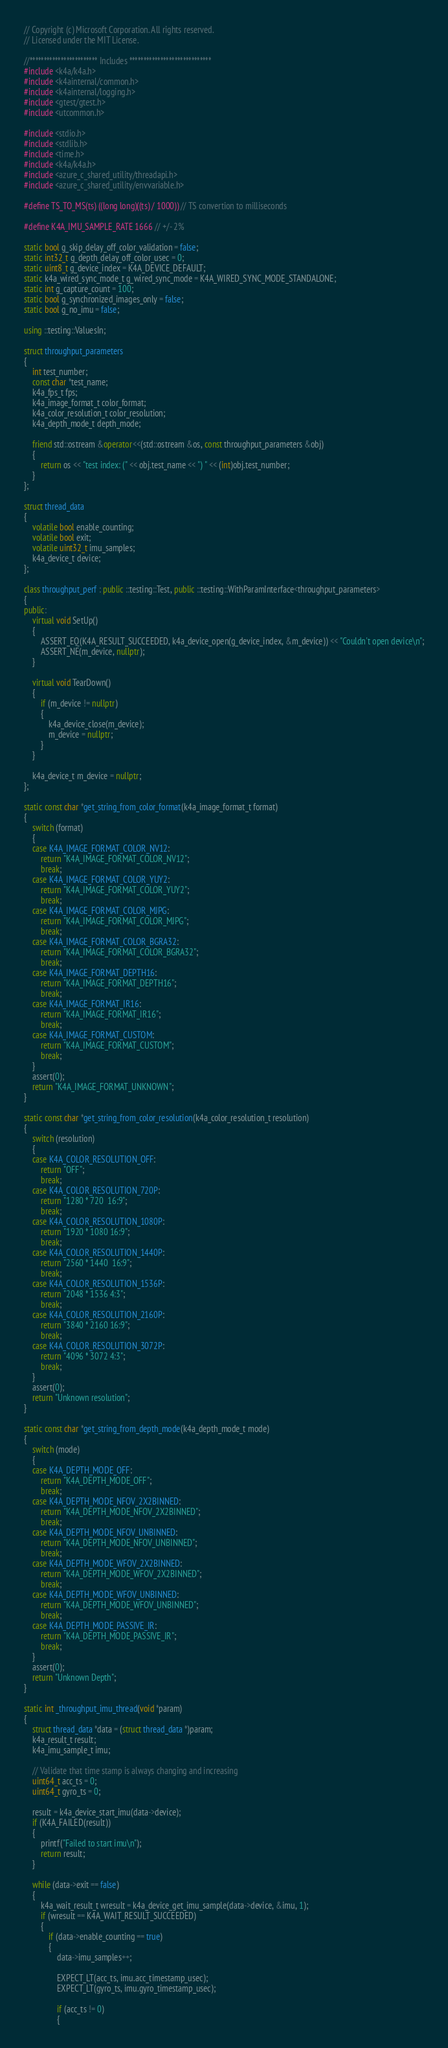<code> <loc_0><loc_0><loc_500><loc_500><_C++_>// Copyright (c) Microsoft Corporation. All rights reserved.
// Licensed under the MIT License.

//************************ Includes *****************************
#include <k4a/k4a.h>
#include <k4ainternal/common.h>
#include <k4ainternal/logging.h>
#include <gtest/gtest.h>
#include <utcommon.h>

#include <stdio.h>
#include <stdlib.h>
#include <time.h>
#include <k4a/k4a.h>
#include <azure_c_shared_utility/threadapi.h>
#include <azure_c_shared_utility/envvariable.h>

#define TS_TO_MS(ts) ((long long)((ts) / 1000)) // TS convertion to milliseconds

#define K4A_IMU_SAMPLE_RATE 1666 // +/- 2%

static bool g_skip_delay_off_color_validation = false;
static int32_t g_depth_delay_off_color_usec = 0;
static uint8_t g_device_index = K4A_DEVICE_DEFAULT;
static k4a_wired_sync_mode_t g_wired_sync_mode = K4A_WIRED_SYNC_MODE_STANDALONE;
static int g_capture_count = 100;
static bool g_synchronized_images_only = false;
static bool g_no_imu = false;

using ::testing::ValuesIn;

struct throughput_parameters
{
    int test_number;
    const char *test_name;
    k4a_fps_t fps;
    k4a_image_format_t color_format;
    k4a_color_resolution_t color_resolution;
    k4a_depth_mode_t depth_mode;

    friend std::ostream &operator<<(std::ostream &os, const throughput_parameters &obj)
    {
        return os << "test index: (" << obj.test_name << ") " << (int)obj.test_number;
    }
};

struct thread_data
{
    volatile bool enable_counting;
    volatile bool exit;
    volatile uint32_t imu_samples;
    k4a_device_t device;
};

class throughput_perf : public ::testing::Test, public ::testing::WithParamInterface<throughput_parameters>
{
public:
    virtual void SetUp()
    {
        ASSERT_EQ(K4A_RESULT_SUCCEEDED, k4a_device_open(g_device_index, &m_device)) << "Couldn't open device\n";
        ASSERT_NE(m_device, nullptr);
    }

    virtual void TearDown()
    {
        if (m_device != nullptr)
        {
            k4a_device_close(m_device);
            m_device = nullptr;
        }
    }

    k4a_device_t m_device = nullptr;
};

static const char *get_string_from_color_format(k4a_image_format_t format)
{
    switch (format)
    {
    case K4A_IMAGE_FORMAT_COLOR_NV12:
        return "K4A_IMAGE_FORMAT_COLOR_NV12";
        break;
    case K4A_IMAGE_FORMAT_COLOR_YUY2:
        return "K4A_IMAGE_FORMAT_COLOR_YUY2";
        break;
    case K4A_IMAGE_FORMAT_COLOR_MJPG:
        return "K4A_IMAGE_FORMAT_COLOR_MJPG";
        break;
    case K4A_IMAGE_FORMAT_COLOR_BGRA32:
        return "K4A_IMAGE_FORMAT_COLOR_BGRA32";
        break;
    case K4A_IMAGE_FORMAT_DEPTH16:
        return "K4A_IMAGE_FORMAT_DEPTH16";
        break;
    case K4A_IMAGE_FORMAT_IR16:
        return "K4A_IMAGE_FORMAT_IR16";
        break;
    case K4A_IMAGE_FORMAT_CUSTOM:
        return "K4A_IMAGE_FORMAT_CUSTOM";
        break;
    }
    assert(0);
    return "K4A_IMAGE_FORMAT_UNKNOWN";
}

static const char *get_string_from_color_resolution(k4a_color_resolution_t resolution)
{
    switch (resolution)
    {
    case K4A_COLOR_RESOLUTION_OFF:
        return "OFF";
        break;
    case K4A_COLOR_RESOLUTION_720P:
        return "1280 * 720  16:9";
        break;
    case K4A_COLOR_RESOLUTION_1080P:
        return "1920 * 1080 16:9";
        break;
    case K4A_COLOR_RESOLUTION_1440P:
        return "2560 * 1440  16:9";
        break;
    case K4A_COLOR_RESOLUTION_1536P:
        return "2048 * 1536 4:3";
        break;
    case K4A_COLOR_RESOLUTION_2160P:
        return "3840 * 2160 16:9";
        break;
    case K4A_COLOR_RESOLUTION_3072P:
        return "4096 * 3072 4:3";
        break;
    }
    assert(0);
    return "Unknown resolution";
}

static const char *get_string_from_depth_mode(k4a_depth_mode_t mode)
{
    switch (mode)
    {
    case K4A_DEPTH_MODE_OFF:
        return "K4A_DEPTH_MODE_OFF";
        break;
    case K4A_DEPTH_MODE_NFOV_2X2BINNED:
        return "K4A_DEPTH_MODE_NFOV_2X2BINNED";
        break;
    case K4A_DEPTH_MODE_NFOV_UNBINNED:
        return "K4A_DEPTH_MODE_NFOV_UNBINNED";
        break;
    case K4A_DEPTH_MODE_WFOV_2X2BINNED:
        return "K4A_DEPTH_MODE_WFOV_2X2BINNED";
        break;
    case K4A_DEPTH_MODE_WFOV_UNBINNED:
        return "K4A_DEPTH_MODE_WFOV_UNBINNED";
        break;
    case K4A_DEPTH_MODE_PASSIVE_IR:
        return "K4A_DEPTH_MODE_PASSIVE_IR";
        break;
    }
    assert(0);
    return "Unknown Depth";
}

static int _throughput_imu_thread(void *param)
{
    struct thread_data *data = (struct thread_data *)param;
    k4a_result_t result;
    k4a_imu_sample_t imu;

    // Validate that time stamp is always changing and increasing
    uint64_t acc_ts = 0;
    uint64_t gyro_ts = 0;

    result = k4a_device_start_imu(data->device);
    if (K4A_FAILED(result))
    {
        printf("Failed to start imu\n");
        return result;
    }

    while (data->exit == false)
    {
        k4a_wait_result_t wresult = k4a_device_get_imu_sample(data->device, &imu, 1);
        if (wresult == K4A_WAIT_RESULT_SUCCEEDED)
        {
            if (data->enable_counting == true)
            {
                data->imu_samples++;

                EXPECT_LT(acc_ts, imu.acc_timestamp_usec);
                EXPECT_LT(gyro_ts, imu.gyro_timestamp_usec);

                if (acc_ts != 0)
                {</code> 